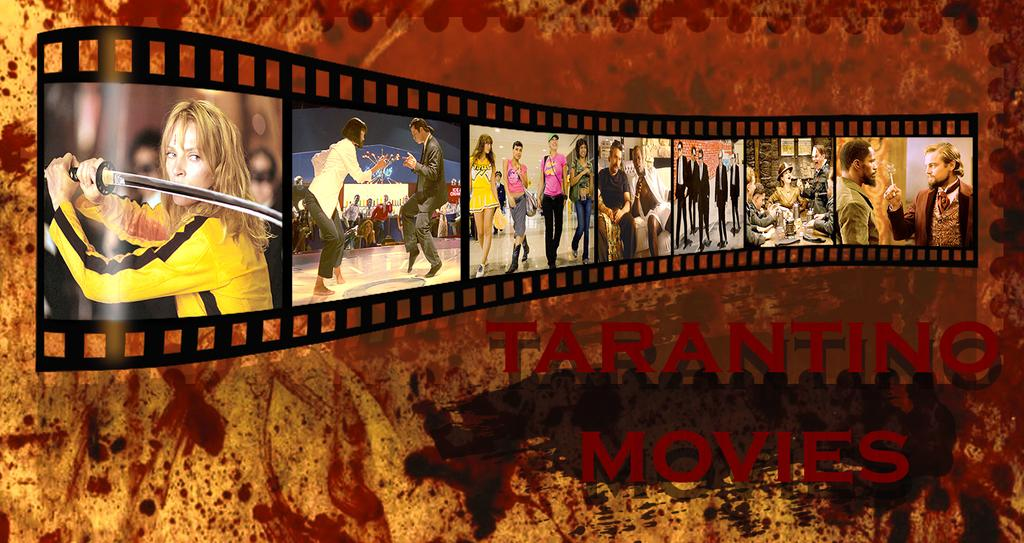Who or what can be seen in the image? There are people in the image. What object is present in the image? There is a reel in the image. What else can be found in the image? There is some information in the image. What type of cheese is being used to wind the reel in the image? There is no cheese present in the image, and the reel is not being wound with any cheese. 